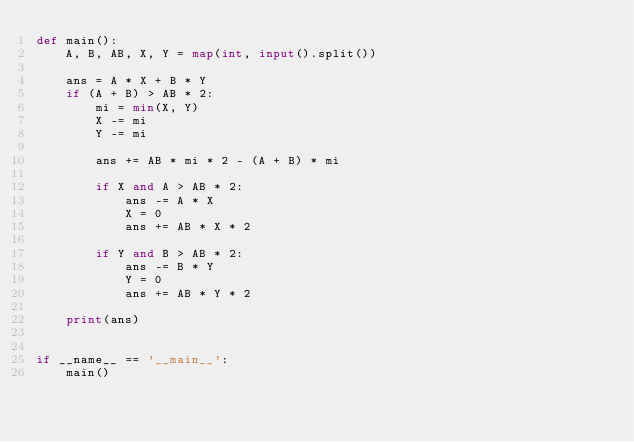<code> <loc_0><loc_0><loc_500><loc_500><_Python_>def main():
    A, B, AB, X, Y = map(int, input().split())

    ans = A * X + B * Y
    if (A + B) > AB * 2:
        mi = min(X, Y)
        X -= mi
        Y -= mi

        ans += AB * mi * 2 - (A + B) * mi

        if X and A > AB * 2:
            ans -= A * X
            X = 0
            ans += AB * X * 2

        if Y and B > AB * 2:
            ans -= B * Y
            Y = 0
            ans += AB * Y * 2

    print(ans)


if __name__ == '__main__':
    main()
</code> 